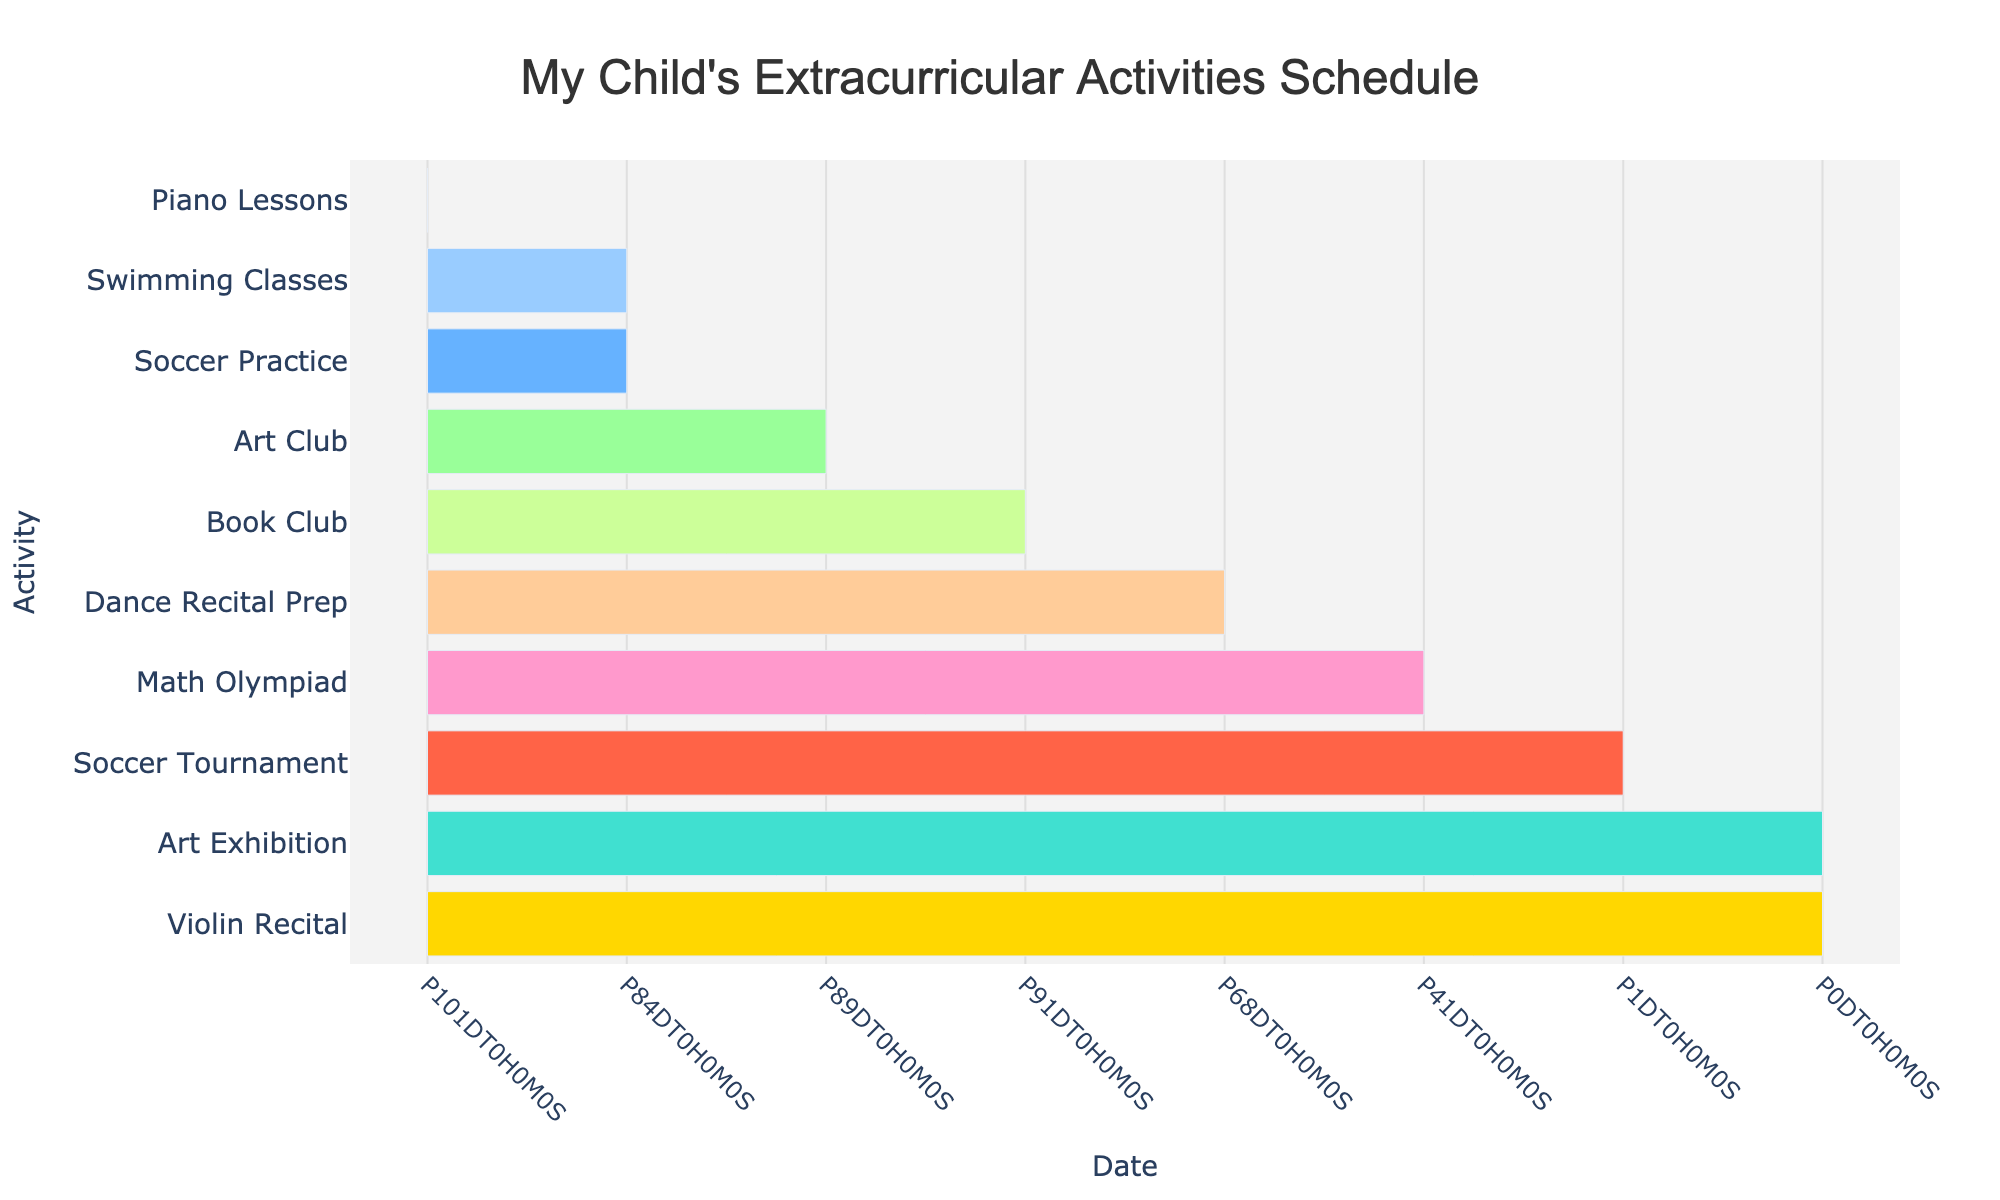What's the title of the Gantt Chart? The title is usually displayed at the top of the chart. In this case, it reads "My Child's Extracurricular Activities Schedule".
Answer: "My Child's Extracurricular Activities Schedule" How many activities span the entire semester? To find the activities that span from the start of the semester to nearly the end, look at the start and end dates for each activity. Here, Piano Lessons, Art Club, and Book Club span over most of the semester.
Answer: 3 Which activity starts last? Checking the start dates, Dance Recital Prep begins on October 1st, which is the latest among the activities.
Answer: Dance Recital Prep Which two activities end on December 15th? By reviewing the end dates, you can see that Piano Lessons and Book Club finish on December 15th.
Answer: Piano Lessons and Book Club What is the range of dates for Swimming Classes? To find the range, look at the start and end dates for Swimming Classes. It starts on September 6th and ends on November 29th.
Answer: September 6 to November 29 Which event has the shortest duration? By comparing the start and end dates, Violin Recital is a single-day event, lasting only one day, December 16.
Answer: Violin Recital Compare the start dates of Piano Lessons and Soccer Practice. Which starts earlier? Piano Lessons starts on September 5th and Soccer Practice starts on September 7th. Therefore, Piano Lessons starts earlier.
Answer: Piano Lessons How does the duration of Art Club compare to Math Olympiad? Art Club runs from September 12th to December 10th, whereas Math Olympiad runs from October 15th to November 25th. Art Club lasts longer.
Answer: Art Club What special event occurs on December 2nd and 3rd? Noticing the special shapes for single events, the Gantt Chart shows the Soccer Tournament on these specific dates.
Answer: Soccer Tournament 